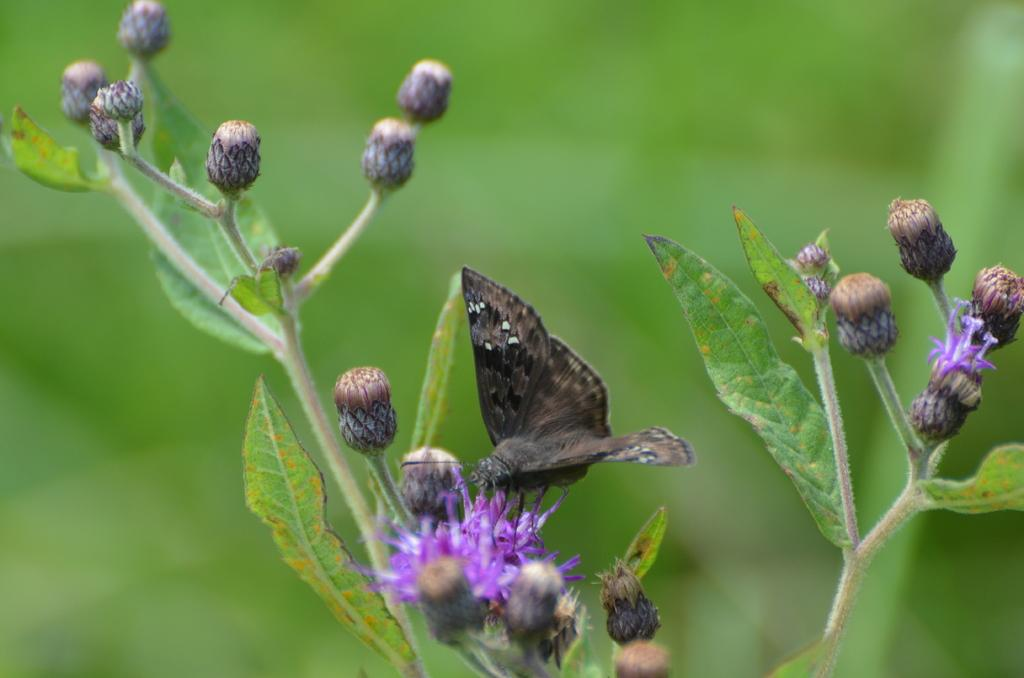What is present in the image? There is a plant in the image. Can you describe the plant in more detail? The plant has buds and leaves on its stem, and there is a flower on the plant. What is interacting with the plant in the image? A butterfly is sitting on the flower. How would you describe the background of the image? The background of the image is blurry. What nation is playing a game in the image? There is no nation or game present in the image; it features a plant with a butterfly sitting on a flower. What type of wool is being used to create the flower in the image? The flower in the image is a natural part of the plant and does not involve any wool. 